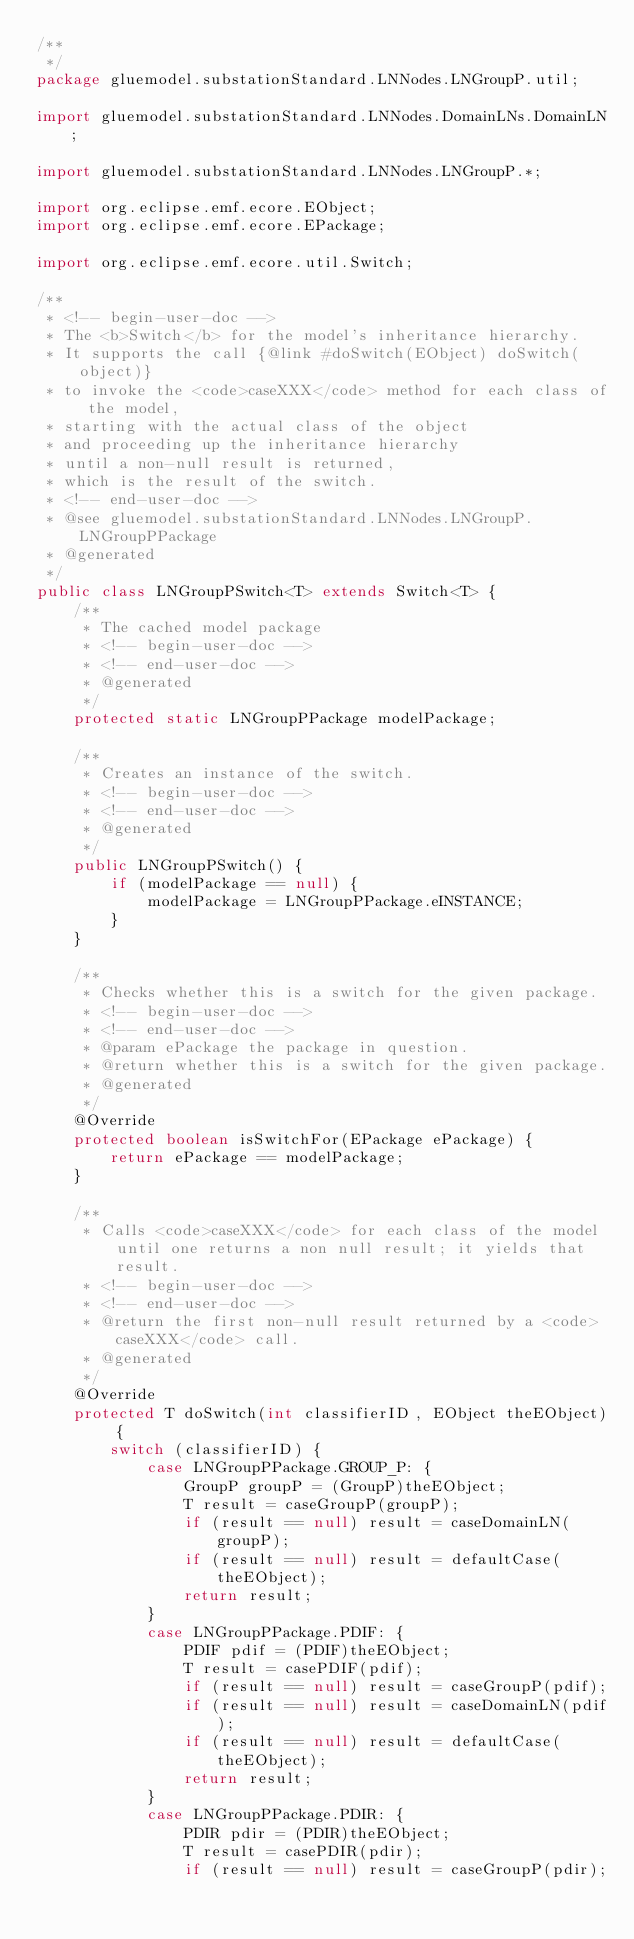Convert code to text. <code><loc_0><loc_0><loc_500><loc_500><_Java_>/**
 */
package gluemodel.substationStandard.LNNodes.LNGroupP.util;

import gluemodel.substationStandard.LNNodes.DomainLNs.DomainLN;

import gluemodel.substationStandard.LNNodes.LNGroupP.*;

import org.eclipse.emf.ecore.EObject;
import org.eclipse.emf.ecore.EPackage;

import org.eclipse.emf.ecore.util.Switch;

/**
 * <!-- begin-user-doc -->
 * The <b>Switch</b> for the model's inheritance hierarchy.
 * It supports the call {@link #doSwitch(EObject) doSwitch(object)}
 * to invoke the <code>caseXXX</code> method for each class of the model,
 * starting with the actual class of the object
 * and proceeding up the inheritance hierarchy
 * until a non-null result is returned,
 * which is the result of the switch.
 * <!-- end-user-doc -->
 * @see gluemodel.substationStandard.LNNodes.LNGroupP.LNGroupPPackage
 * @generated
 */
public class LNGroupPSwitch<T> extends Switch<T> {
	/**
	 * The cached model package
	 * <!-- begin-user-doc -->
	 * <!-- end-user-doc -->
	 * @generated
	 */
	protected static LNGroupPPackage modelPackage;

	/**
	 * Creates an instance of the switch.
	 * <!-- begin-user-doc -->
	 * <!-- end-user-doc -->
	 * @generated
	 */
	public LNGroupPSwitch() {
		if (modelPackage == null) {
			modelPackage = LNGroupPPackage.eINSTANCE;
		}
	}

	/**
	 * Checks whether this is a switch for the given package.
	 * <!-- begin-user-doc -->
	 * <!-- end-user-doc -->
	 * @param ePackage the package in question.
	 * @return whether this is a switch for the given package.
	 * @generated
	 */
	@Override
	protected boolean isSwitchFor(EPackage ePackage) {
		return ePackage == modelPackage;
	}

	/**
	 * Calls <code>caseXXX</code> for each class of the model until one returns a non null result; it yields that result.
	 * <!-- begin-user-doc -->
	 * <!-- end-user-doc -->
	 * @return the first non-null result returned by a <code>caseXXX</code> call.
	 * @generated
	 */
	@Override
	protected T doSwitch(int classifierID, EObject theEObject) {
		switch (classifierID) {
			case LNGroupPPackage.GROUP_P: {
				GroupP groupP = (GroupP)theEObject;
				T result = caseGroupP(groupP);
				if (result == null) result = caseDomainLN(groupP);
				if (result == null) result = defaultCase(theEObject);
				return result;
			}
			case LNGroupPPackage.PDIF: {
				PDIF pdif = (PDIF)theEObject;
				T result = casePDIF(pdif);
				if (result == null) result = caseGroupP(pdif);
				if (result == null) result = caseDomainLN(pdif);
				if (result == null) result = defaultCase(theEObject);
				return result;
			}
			case LNGroupPPackage.PDIR: {
				PDIR pdir = (PDIR)theEObject;
				T result = casePDIR(pdir);
				if (result == null) result = caseGroupP(pdir);</code> 